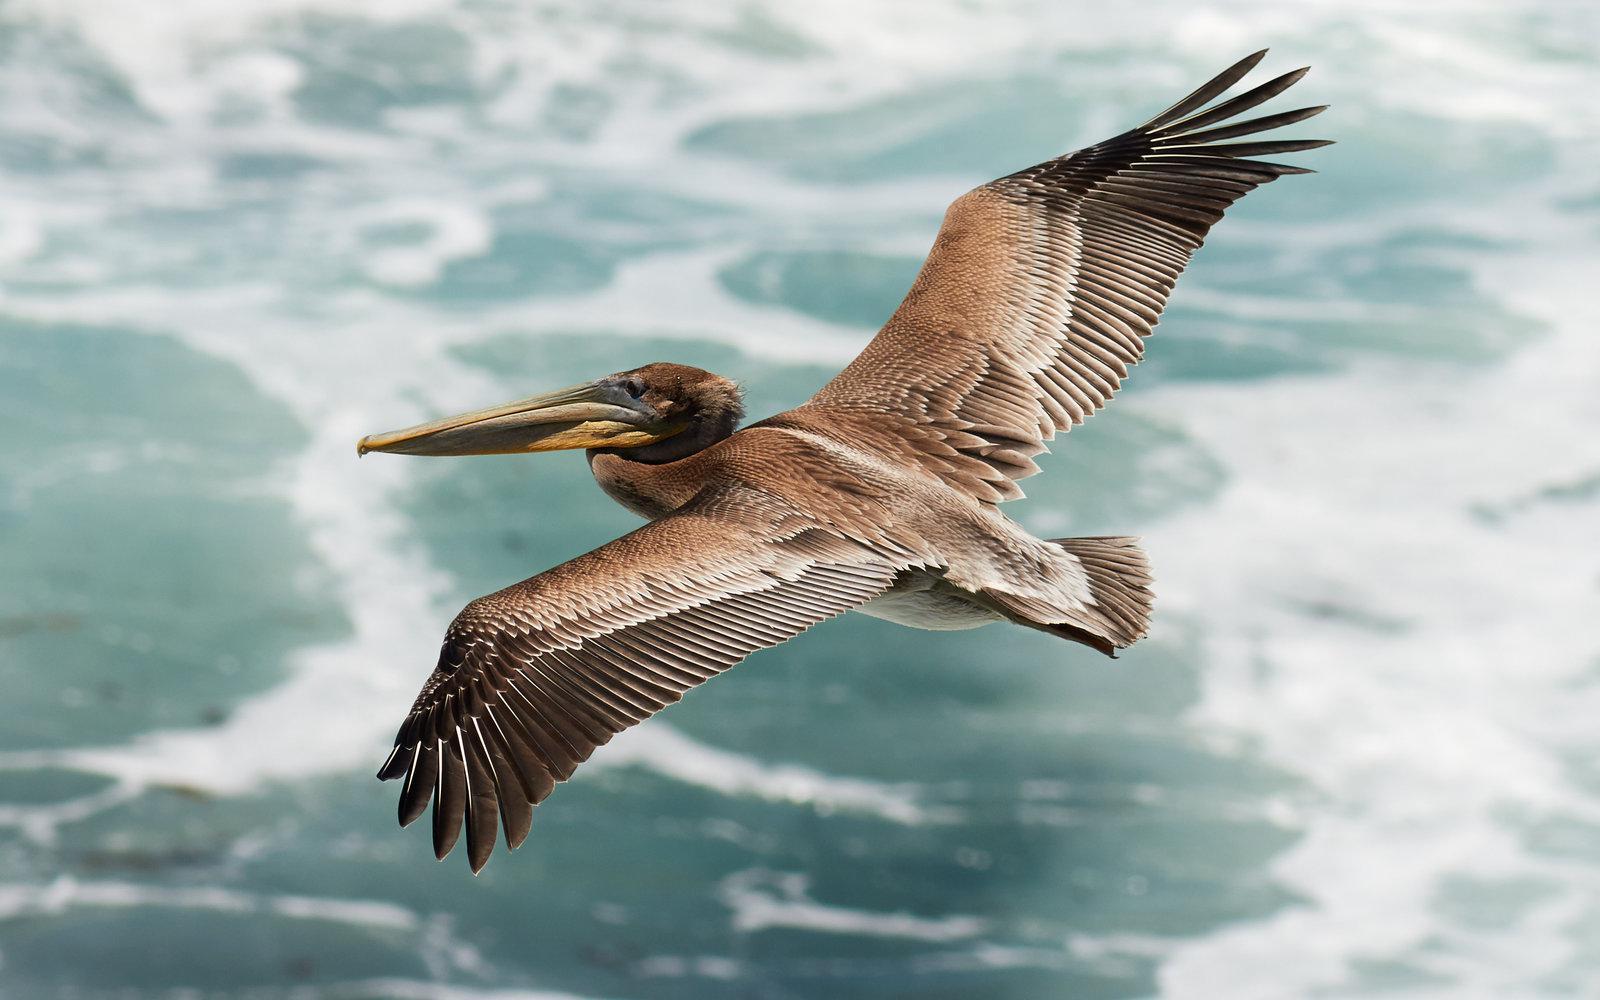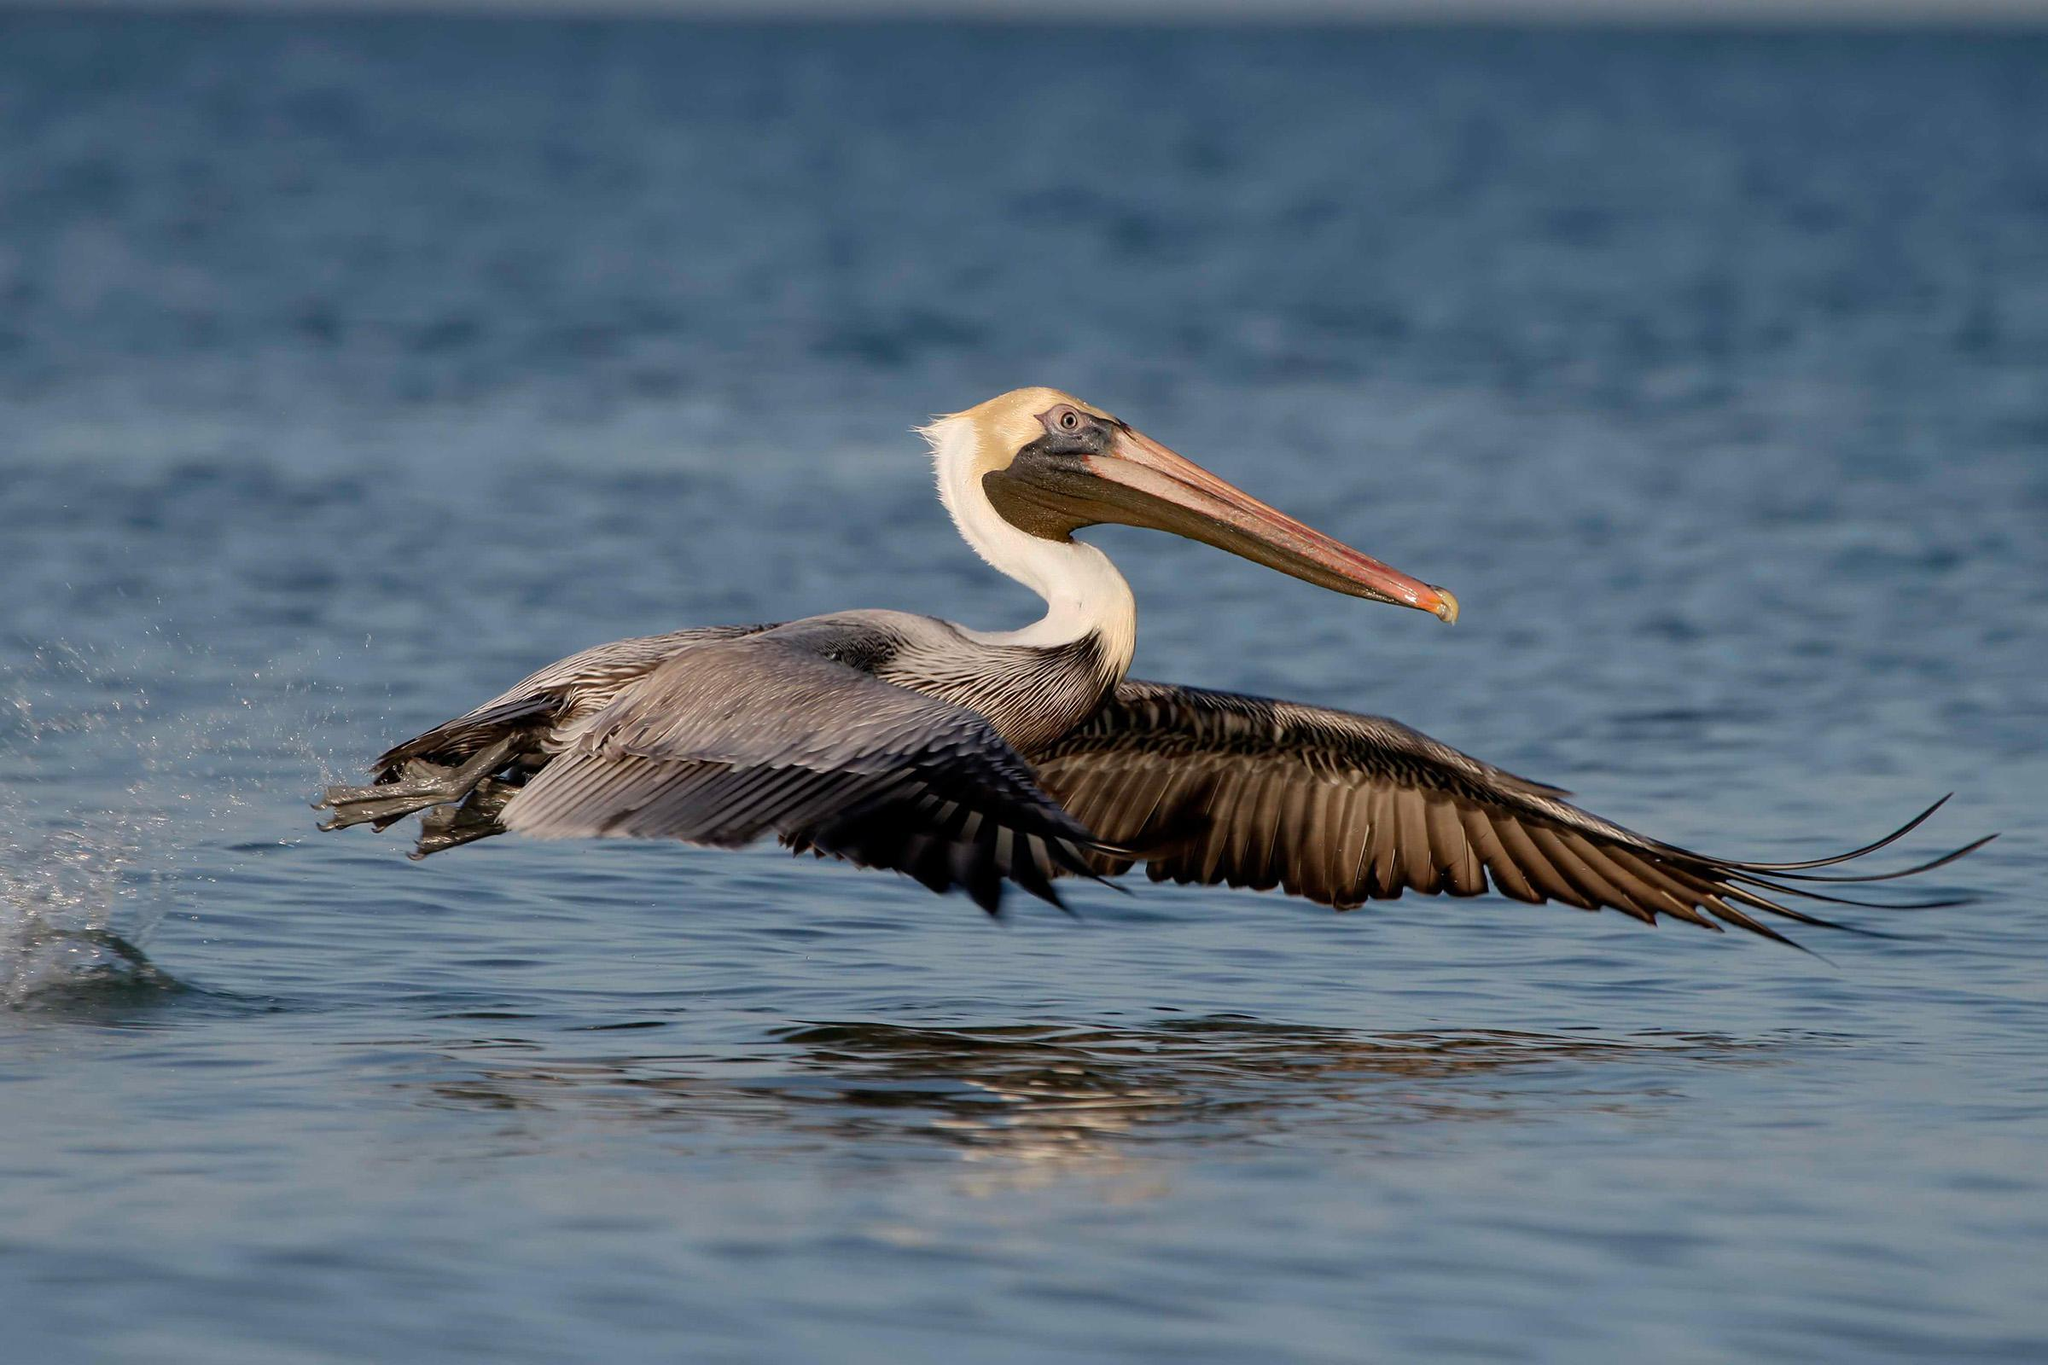The first image is the image on the left, the second image is the image on the right. For the images displayed, is the sentence "Two long-beaked birds are shown in flight, both with wings outspread, but one with them pointed downward, and the other with them pointed upward." factually correct? Answer yes or no. Yes. The first image is the image on the left, the second image is the image on the right. Evaluate the accuracy of this statement regarding the images: "A bird is perched on a rock.". Is it true? Answer yes or no. No. 